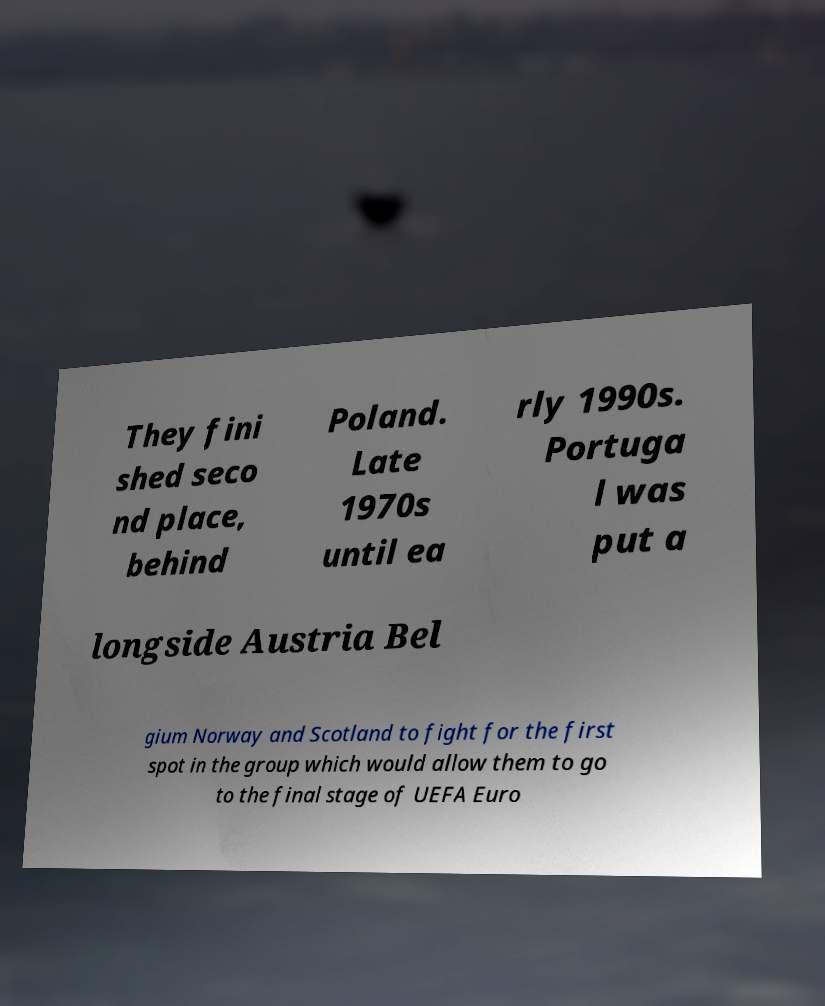Please identify and transcribe the text found in this image. They fini shed seco nd place, behind Poland. Late 1970s until ea rly 1990s. Portuga l was put a longside Austria Bel gium Norway and Scotland to fight for the first spot in the group which would allow them to go to the final stage of UEFA Euro 